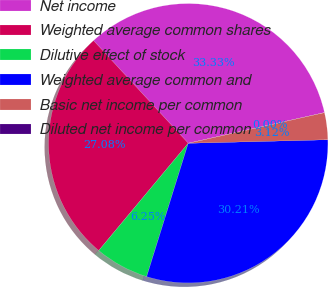Convert chart. <chart><loc_0><loc_0><loc_500><loc_500><pie_chart><fcel>Net income<fcel>Weighted average common shares<fcel>Dilutive effect of stock<fcel>Weighted average common and<fcel>Basic net income per common<fcel>Diluted net income per common<nl><fcel>33.33%<fcel>27.08%<fcel>6.25%<fcel>30.21%<fcel>3.12%<fcel>0.0%<nl></chart> 